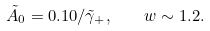Convert formula to latex. <formula><loc_0><loc_0><loc_500><loc_500>\tilde { A } _ { 0 } = 0 . 1 0 / \tilde { \gamma } _ { + } , \quad w \sim 1 . 2 .</formula> 